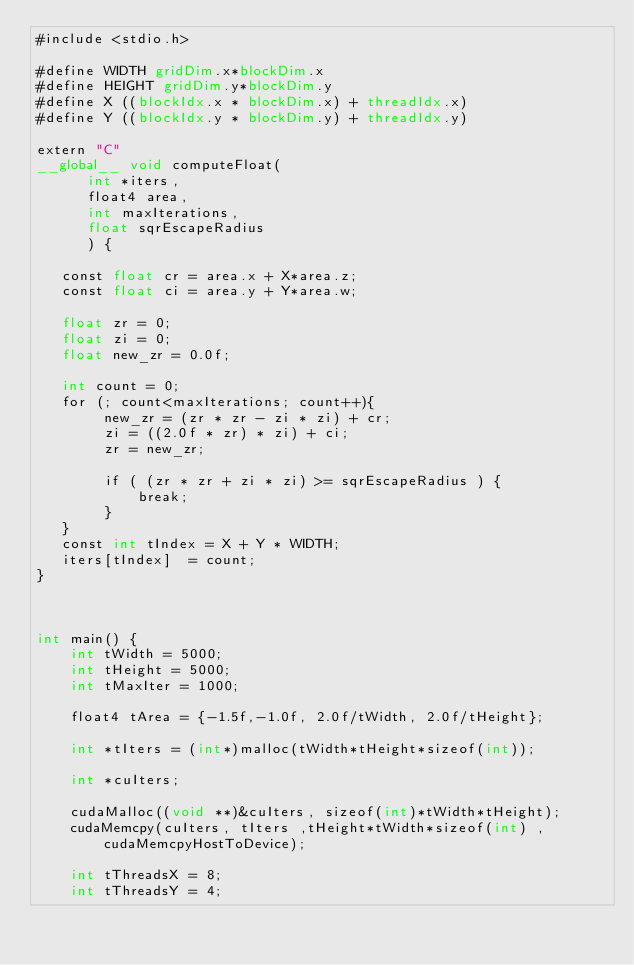<code> <loc_0><loc_0><loc_500><loc_500><_Cuda_>#include <stdio.h>

#define WIDTH gridDim.x*blockDim.x
#define HEIGHT gridDim.y*blockDim.y
#define X ((blockIdx.x * blockDim.x) + threadIdx.x)
#define Y ((blockIdx.y * blockDim.y) + threadIdx.y)

extern "C"
__global__ void computeFloat(
      int *iters,
      float4 area,
      int maxIterations,
      float sqrEscapeRadius
      ) {

   const float cr = area.x + X*area.z;
   const float ci = area.y + Y*area.w;

   float zr = 0;
   float zi = 0;
   float new_zr = 0.0f;

   int count = 0;
   for (; count<maxIterations; count++){
        new_zr = (zr * zr - zi * zi) + cr;
        zi = ((2.0f * zr) * zi) + ci;
        zr = new_zr;

        if ( (zr * zr + zi * zi) >= sqrEscapeRadius ) {
            break;
        }
   }
   const int tIndex = X + Y * WIDTH;
   iters[tIndex]  = count;
}



int main() {
    int tWidth = 5000;
    int tHeight = 5000;
    int tMaxIter = 1000;

    float4 tArea = {-1.5f,-1.0f, 2.0f/tWidth, 2.0f/tHeight};

    int *tIters = (int*)malloc(tWidth*tHeight*sizeof(int));

    int *cuIters;

    cudaMalloc((void **)&cuIters, sizeof(int)*tWidth*tHeight);
    cudaMemcpy(cuIters, tIters ,tHeight*tWidth*sizeof(int) ,cudaMemcpyHostToDevice);

    int tThreadsX = 8;
    int tThreadsY = 4;
</code> 